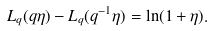Convert formula to latex. <formula><loc_0><loc_0><loc_500><loc_500>L _ { q } ( q \eta ) - L _ { q } ( q ^ { - 1 } \eta ) = \ln ( 1 + \eta ) .</formula> 